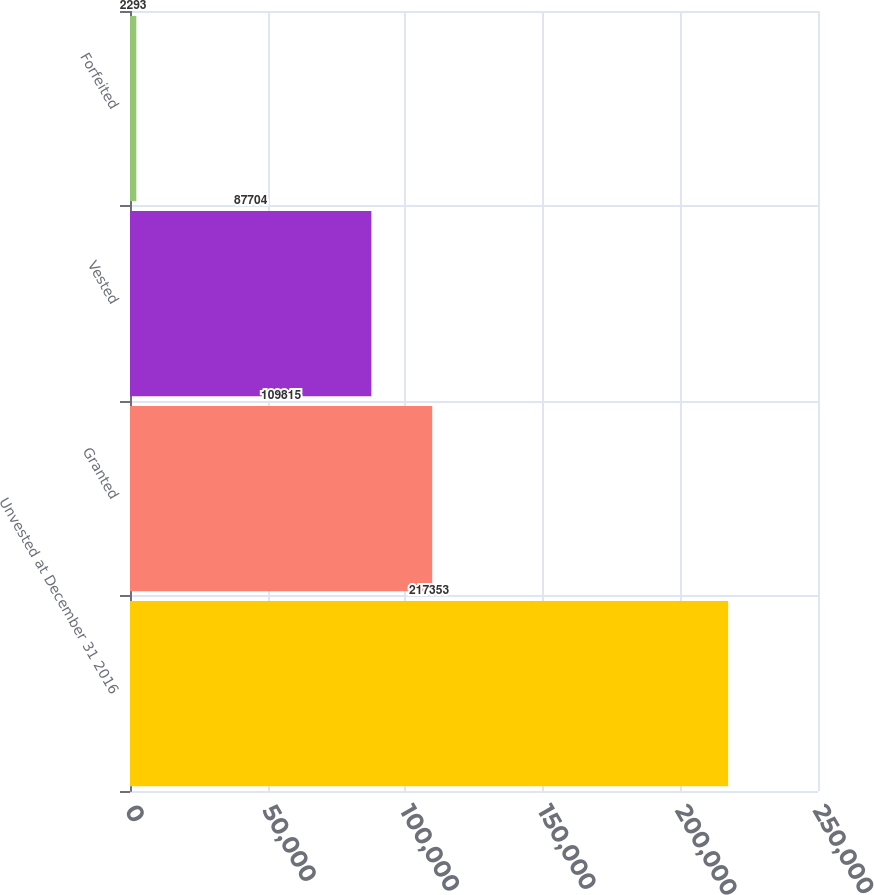Convert chart. <chart><loc_0><loc_0><loc_500><loc_500><bar_chart><fcel>Unvested at December 31 2016<fcel>Granted<fcel>Vested<fcel>Forfeited<nl><fcel>217353<fcel>109815<fcel>87704<fcel>2293<nl></chart> 